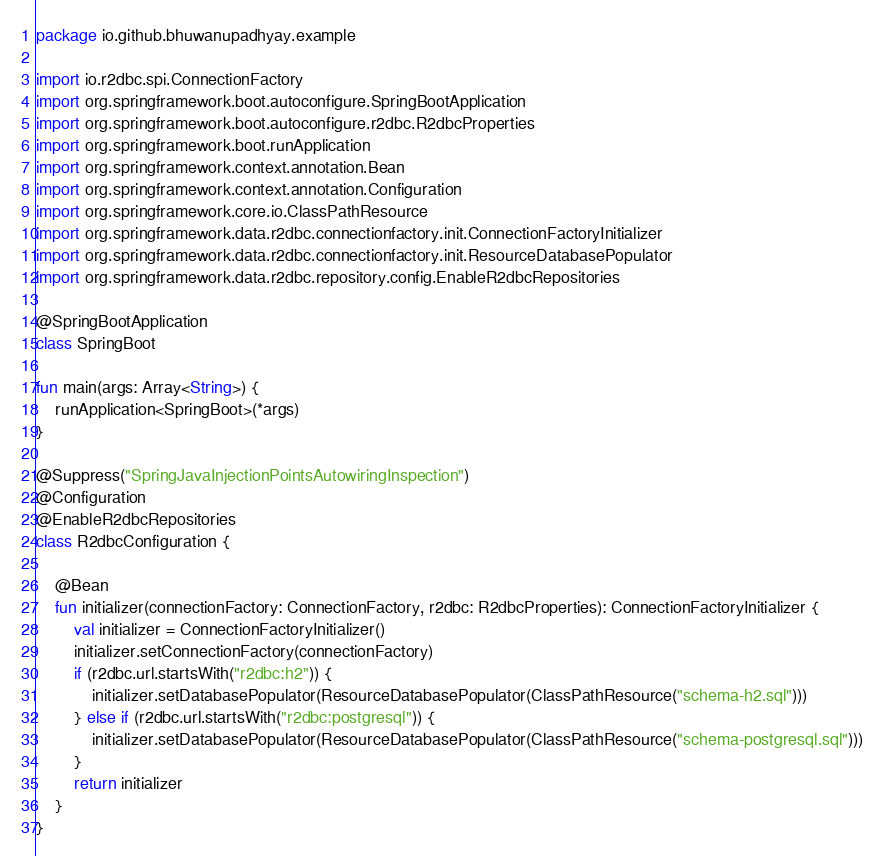<code> <loc_0><loc_0><loc_500><loc_500><_Kotlin_>package io.github.bhuwanupadhyay.example

import io.r2dbc.spi.ConnectionFactory
import org.springframework.boot.autoconfigure.SpringBootApplication
import org.springframework.boot.autoconfigure.r2dbc.R2dbcProperties
import org.springframework.boot.runApplication
import org.springframework.context.annotation.Bean
import org.springframework.context.annotation.Configuration
import org.springframework.core.io.ClassPathResource
import org.springframework.data.r2dbc.connectionfactory.init.ConnectionFactoryInitializer
import org.springframework.data.r2dbc.connectionfactory.init.ResourceDatabasePopulator
import org.springframework.data.r2dbc.repository.config.EnableR2dbcRepositories

@SpringBootApplication
class SpringBoot

fun main(args: Array<String>) {
    runApplication<SpringBoot>(*args)
}

@Suppress("SpringJavaInjectionPointsAutowiringInspection")
@Configuration
@EnableR2dbcRepositories
class R2dbcConfiguration {

    @Bean
    fun initializer(connectionFactory: ConnectionFactory, r2dbc: R2dbcProperties): ConnectionFactoryInitializer {
        val initializer = ConnectionFactoryInitializer()
        initializer.setConnectionFactory(connectionFactory)
        if (r2dbc.url.startsWith("r2dbc:h2")) {
            initializer.setDatabasePopulator(ResourceDatabasePopulator(ClassPathResource("schema-h2.sql")))
        } else if (r2dbc.url.startsWith("r2dbc:postgresql")) {
            initializer.setDatabasePopulator(ResourceDatabasePopulator(ClassPathResource("schema-postgresql.sql")))
        }
        return initializer
    }
}
</code> 